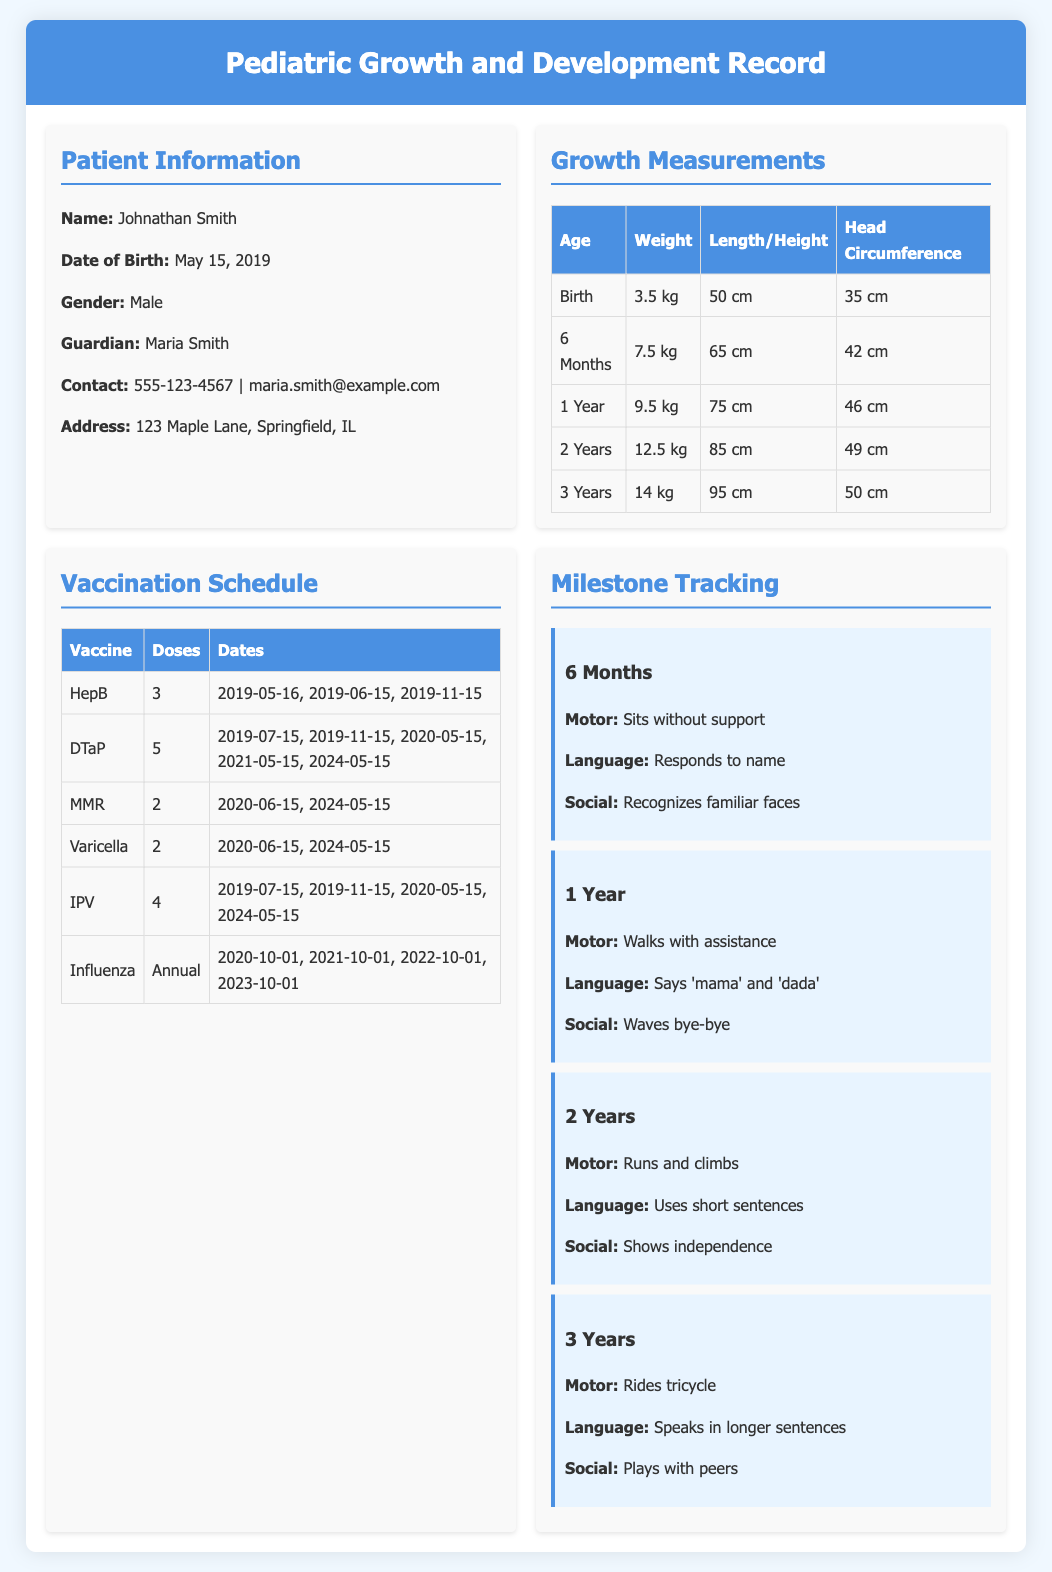What is the patient's name? The document provides details about the patient's information, including the name which is Johnathan Smith.
Answer: Johnathan Smith When was the patient born? The date of birth for the patient is mentioned, which is May 15, 2019.
Answer: May 15, 2019 What is the weight of the patient at 2 years? The growth measurements table lists the weight of the patient at 2 years as 12.5 kg.
Answer: 12.5 kg How many doses of DTaP are scheduled? The vaccination schedule indicates that there are 5 doses of the DTaP vaccine.
Answer: 5 What milestone is achieved at 1 year? The document lists multiple milestones for different ages, where one milestone at 1 year is "Walks with assistance."
Answer: Walks with assistance What is the head circumference at birth? The growth measurements at birth show that the head circumference is 35 cm.
Answer: 35 cm When is the next scheduled influenza vaccine? The vaccination schedule shows that the last recorded date for the influenza vaccine is 2023-10-01, indicating that it would be due annually.
Answer: Annually What does the patient recognize at 6 months? The milestones for 6 months include recognizing familiar faces.
Answer: Recognizes familiar faces How many total vaccines are listed? The document counts the vaccines listed in the vaccination schedule, amounting to six different vaccines.
Answer: 6 